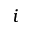<formula> <loc_0><loc_0><loc_500><loc_500>i</formula> 